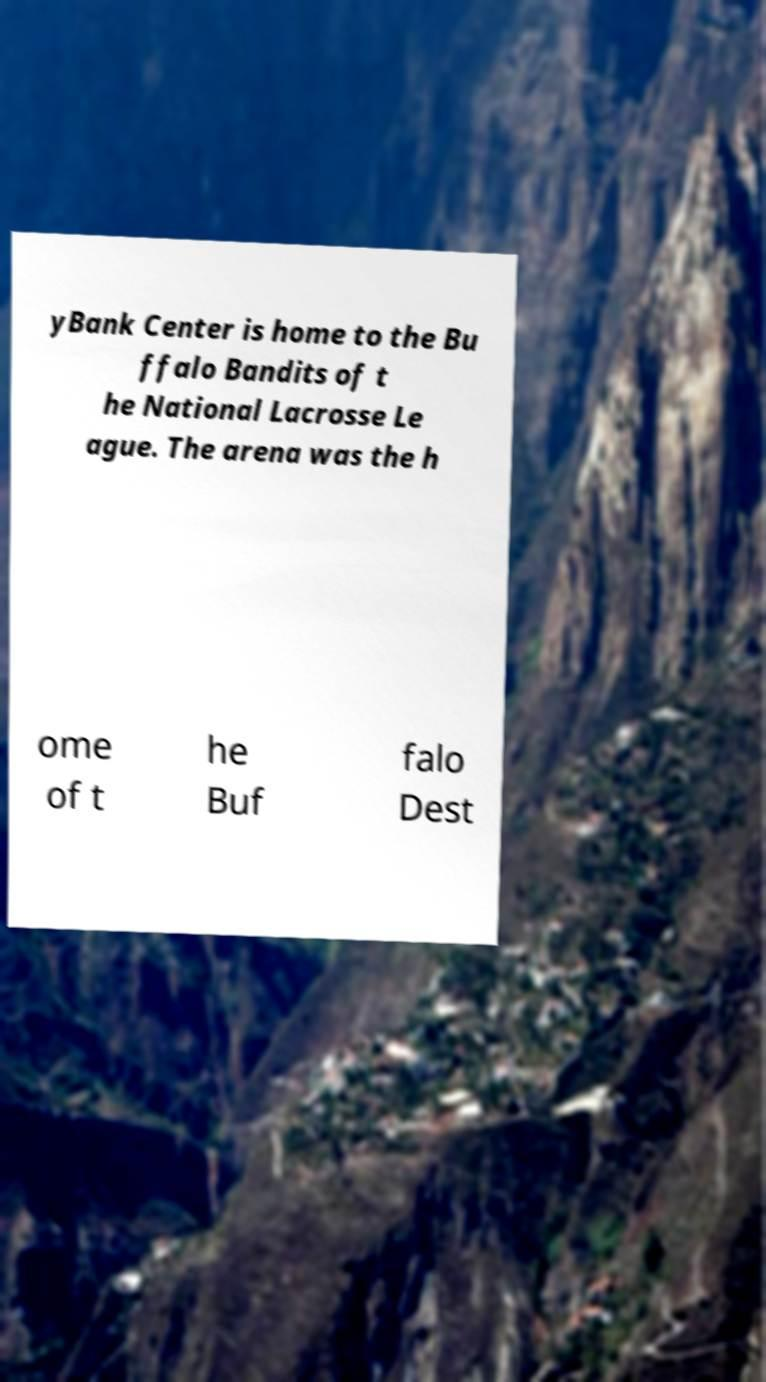What messages or text are displayed in this image? I need them in a readable, typed format. yBank Center is home to the Bu ffalo Bandits of t he National Lacrosse Le ague. The arena was the h ome of t he Buf falo Dest 